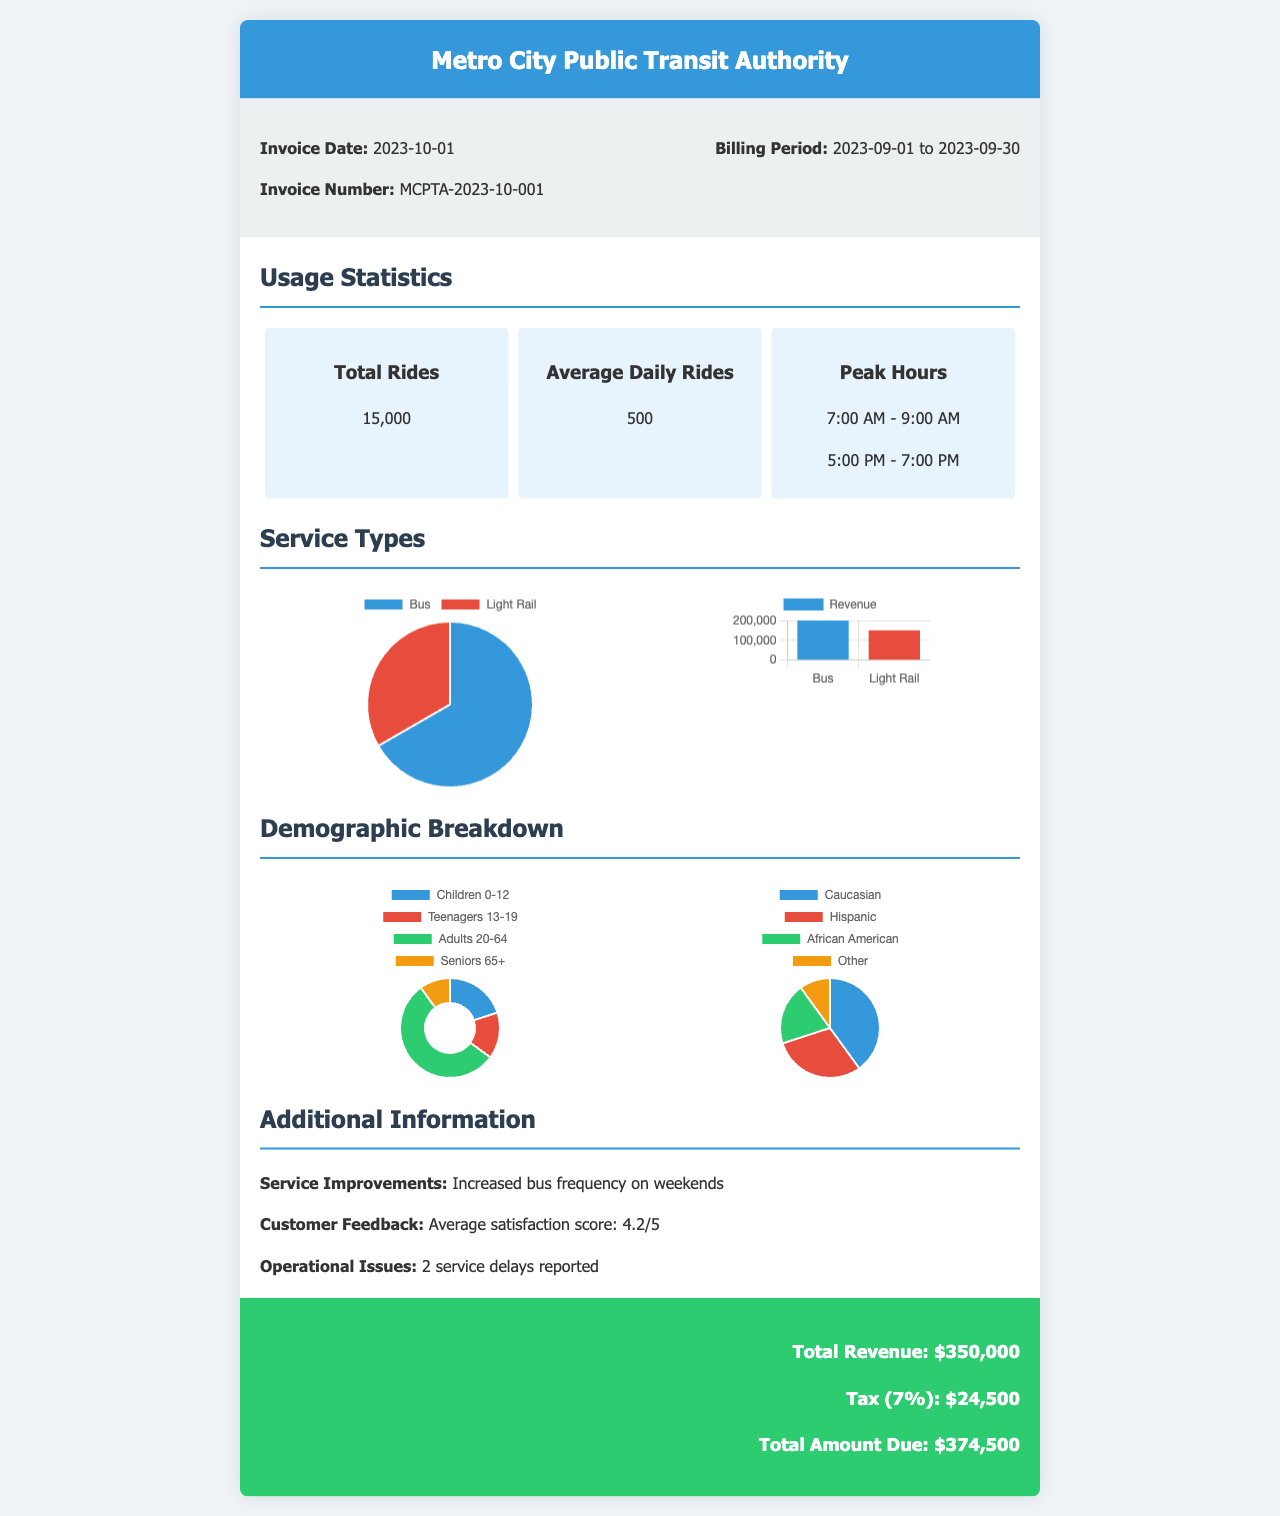What is the invoice number? The invoice number is explicitly stated in the document as MCPTA-2023-10-001.
Answer: MCPTA-2023-10-001 What was the total number of rides during September? The document states that the total number of rides for the month is 15,000.
Answer: 15,000 What is the average daily number of rides? The average daily rides is noted as 500, derived from the total rides divided by the number of operational days.
Answer: 500 What is the total amount due? The total amount due reflects the total revenue plus tax in the document, calculated as $350,000 + $24,500.
Answer: $374,500 What was the average customer satisfaction score? The customer satisfaction score provided in the document is an average of 4.2 out of 5.
Answer: 4.2/5 How many different demographics categories are displayed in the age distribution? The age distribution categorizes into four groups: Children, Teenagers, Adults, and Seniors.
Answer: 4 What service improvements are mentioned? The document outlines service improvements that include increased bus frequency on weekends.
Answer: Increased bus frequency on weekends What were the reported operational issues? Two service delays are specifically noted as operational issues during the billing period.
Answer: 2 service delays What percentage of rides were on buses? The document indicates that 10,000 out of 15,000 rides were on buses, representing approximately 66.7% of total rides.
Answer: 66.7% 